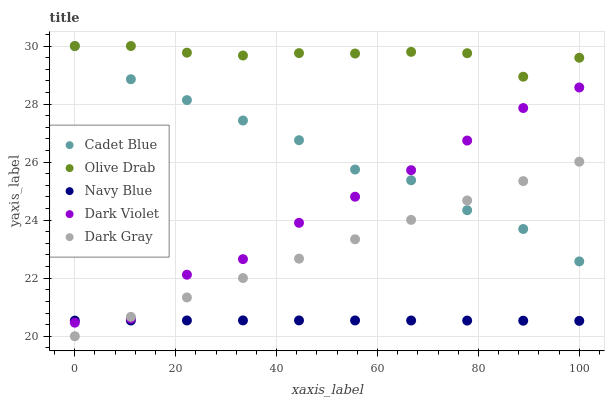Does Navy Blue have the minimum area under the curve?
Answer yes or no. Yes. Does Olive Drab have the maximum area under the curve?
Answer yes or no. Yes. Does Cadet Blue have the minimum area under the curve?
Answer yes or no. No. Does Cadet Blue have the maximum area under the curve?
Answer yes or no. No. Is Dark Gray the smoothest?
Answer yes or no. Yes. Is Dark Violet the roughest?
Answer yes or no. Yes. Is Navy Blue the smoothest?
Answer yes or no. No. Is Navy Blue the roughest?
Answer yes or no. No. Does Dark Gray have the lowest value?
Answer yes or no. Yes. Does Navy Blue have the lowest value?
Answer yes or no. No. Does Olive Drab have the highest value?
Answer yes or no. Yes. Does Navy Blue have the highest value?
Answer yes or no. No. Is Navy Blue less than Cadet Blue?
Answer yes or no. Yes. Is Cadet Blue greater than Navy Blue?
Answer yes or no. Yes. Does Dark Gray intersect Dark Violet?
Answer yes or no. Yes. Is Dark Gray less than Dark Violet?
Answer yes or no. No. Is Dark Gray greater than Dark Violet?
Answer yes or no. No. Does Navy Blue intersect Cadet Blue?
Answer yes or no. No. 